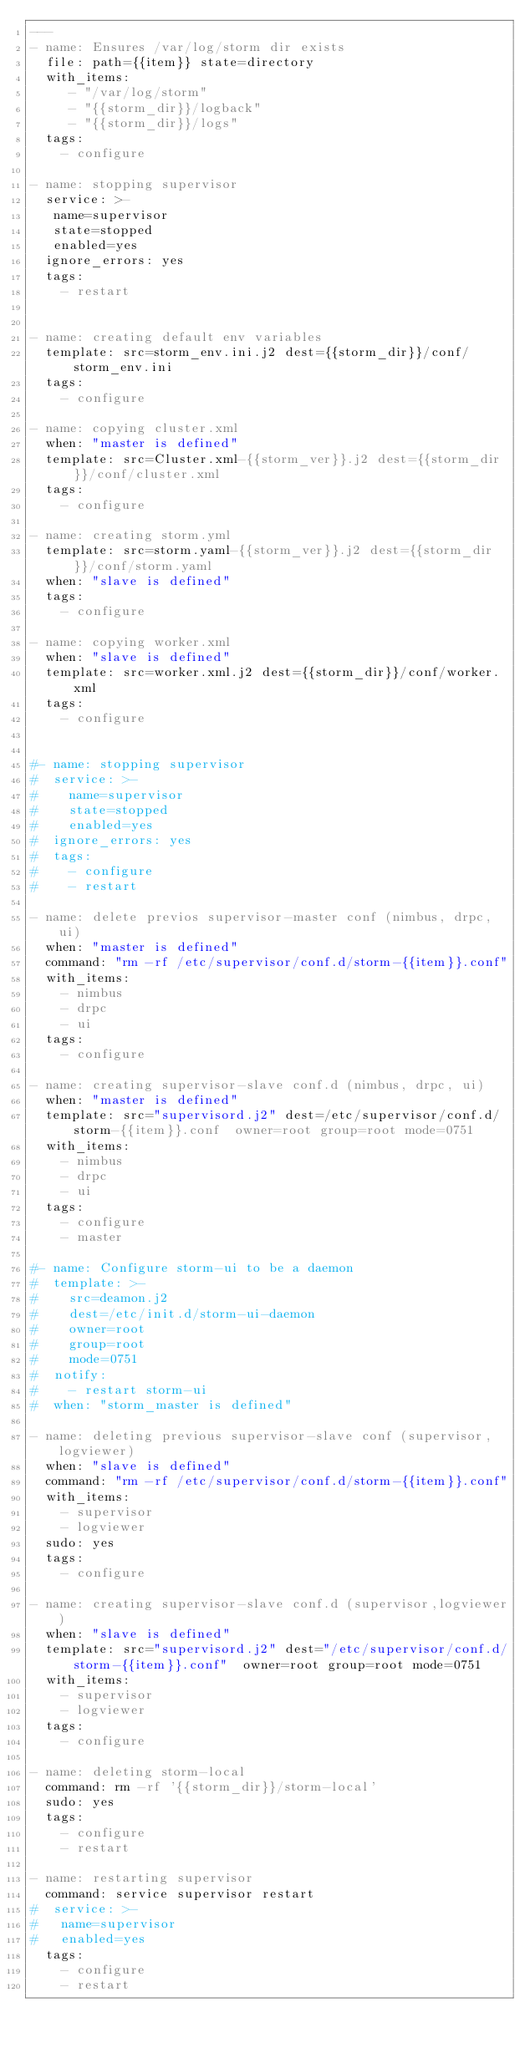<code> <loc_0><loc_0><loc_500><loc_500><_YAML_>---
- name: Ensures /var/log/storm dir exists
  file: path={{item}} state=directory
  with_items:
     - "/var/log/storm"
     - "{{storm_dir}}/logback"
     - "{{storm_dir}}/logs"
  tags:
    - configure

- name: stopping supervisor
  service: >-
   name=supervisor
   state=stopped
   enabled=yes
  ignore_errors: yes
  tags:
    - restart


- name: creating default env variables
  template: src=storm_env.ini.j2 dest={{storm_dir}}/conf/storm_env.ini
  tags:
    - configure

- name: copying cluster.xml
  when: "master is defined"
  template: src=Cluster.xml-{{storm_ver}}.j2 dest={{storm_dir}}/conf/cluster.xml
  tags:
    - configure

- name: creating storm.yml
  template: src=storm.yaml-{{storm_ver}}.j2 dest={{storm_dir}}/conf/storm.yaml
  when: "slave is defined"
  tags:
    - configure

- name: copying worker.xml
  when: "slave is defined"
  template: src=worker.xml.j2 dest={{storm_dir}}/conf/worker.xml
  tags:
    - configure


#- name: stopping supervisor
#  service: >-
#    name=supervisor
#    state=stopped
#    enabled=yes
#  ignore_errors: yes
#  tags:
#    - configure
#    - restart

- name: delete previos supervisor-master conf (nimbus, drpc, ui)
  when: "master is defined"
  command: "rm -rf /etc/supervisor/conf.d/storm-{{item}}.conf"
  with_items:
    - nimbus
    - drpc
    - ui
  tags:
    - configure

- name: creating supervisor-slave conf.d (nimbus, drpc, ui)
  when: "master is defined"
  template: src="supervisord.j2" dest=/etc/supervisor/conf.d/storm-{{item}}.conf  owner=root group=root mode=0751
  with_items:
    - nimbus
    - drpc
    - ui
  tags:
    - configure
    - master

#- name: Configure storm-ui to be a daemon
#  template: >-
#    src=deamon.j2
#    dest=/etc/init.d/storm-ui-daemon
#    owner=root
#    group=root
#    mode=0751
#  notify:
#    - restart storm-ui
#  when: "storm_master is defined"

- name: deleting previous supervisor-slave conf (supervisor,logviewer)
  when: "slave is defined"
  command: "rm -rf /etc/supervisor/conf.d/storm-{{item}}.conf"
  with_items:
    - supervisor
    - logviewer
  sudo: yes
  tags:
    - configure

- name: creating supervisor-slave conf.d (supervisor,logviewer)
  when: "slave is defined"
  template: src="supervisord.j2" dest="/etc/supervisor/conf.d/storm-{{item}}.conf"  owner=root group=root mode=0751
  with_items:
    - supervisor
    - logviewer
  tags:
    - configure

- name: deleting storm-local
  command: rm -rf '{{storm_dir}}/storm-local'
  sudo: yes
  tags:
    - configure
    - restart

- name: restarting supervisor
  command: service supervisor restart
#  service: >-
#   name=supervisor
#   enabled=yes
  tags:
    - configure
    - restart






</code> 